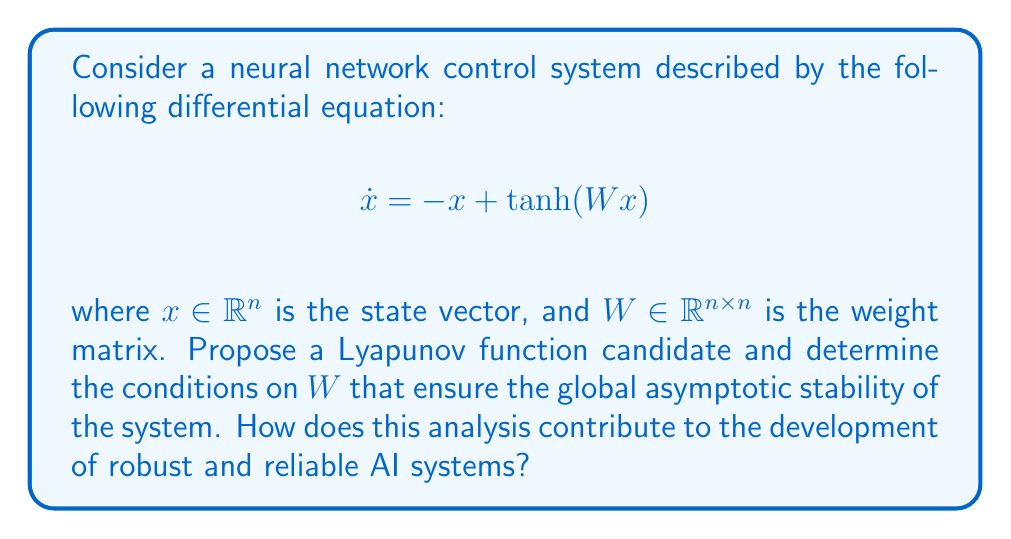Solve this math problem. To analyze the stability of this neural network control system using Lyapunov methods, we follow these steps:

1) Propose a Lyapunov function candidate:
   Let's consider a quadratic Lyapunov function candidate:
   $$V(x) = \frac{1}{2}x^Tx$$

2) Calculate the derivative of V along the system trajectories:
   $$\dot{V}(x) = x^T\dot{x} = x^T(-x + \tanh(Wx))$$

3) Use the property of tanh function:
   For any scalar $z$, $|tanh(z)| < |z|$. Extending this to vectors:
   $$\|\tanh(Wx)\| \leq \|Wx\| \leq \|W\|\|x\|$$
   where $\|W\|$ denotes the induced 2-norm (maximum singular value) of $W$.

4) Upper bound $\dot{V}(x)$:
   $$\dot{V}(x) = x^T(-x + \tanh(Wx)) \leq -\|x\|^2 + \|x\|\|\tanh(Wx)\|$$
   $$\dot{V}(x) \leq -\|x\|^2 + \|W\|\|x\|^2 = -(1-\|W\|)\|x\|^2$$

5) Determine stability condition:
   For global asymptotic stability, we need $\dot{V}(x) < 0$ for all $x \neq 0$. This is ensured if:
   $$1-\|W\| > 0$$
   $$\|W\| < 1$$

This analysis contributes to the development of robust and reliable AI systems by:

1) Providing a mathematical framework to ensure stability in neural network-based control systems.
2) Offering a quantitative criterion ($\|W\| < 1$) for designing stable neural networks.
3) Demonstrating the use of rigorous mathematical methods (Lyapunov stability theory) in AI system analysis, which aligns with evidence-based practices in AI development.
4) Highlighting the importance of weight matrix constraints in neural networks, which can inform training algorithms and architecture design.
5) Enabling the development of provably stable AI systems, which is crucial for safety-critical applications.
Answer: The neural network control system is globally asymptotically stable if the weight matrix $W$ satisfies the condition $\|W\| < 1$, where $\|W\|$ is the induced 2-norm (maximum singular value) of $W$. 